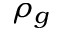Convert formula to latex. <formula><loc_0><loc_0><loc_500><loc_500>\rho _ { g }</formula> 